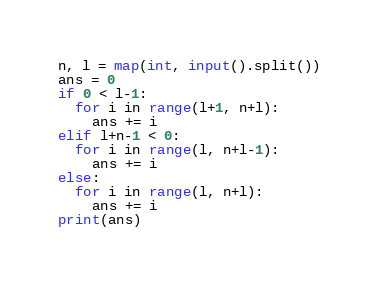Convert code to text. <code><loc_0><loc_0><loc_500><loc_500><_Python_>n, l = map(int, input().split())
ans = 0
if 0 < l-1:
  for i in range(l+1, n+l):
    ans += i
elif l+n-1 < 0:
  for i in range(l, n+l-1):
    ans += i
else:
  for i in range(l, n+l):
    ans += i
print(ans)</code> 